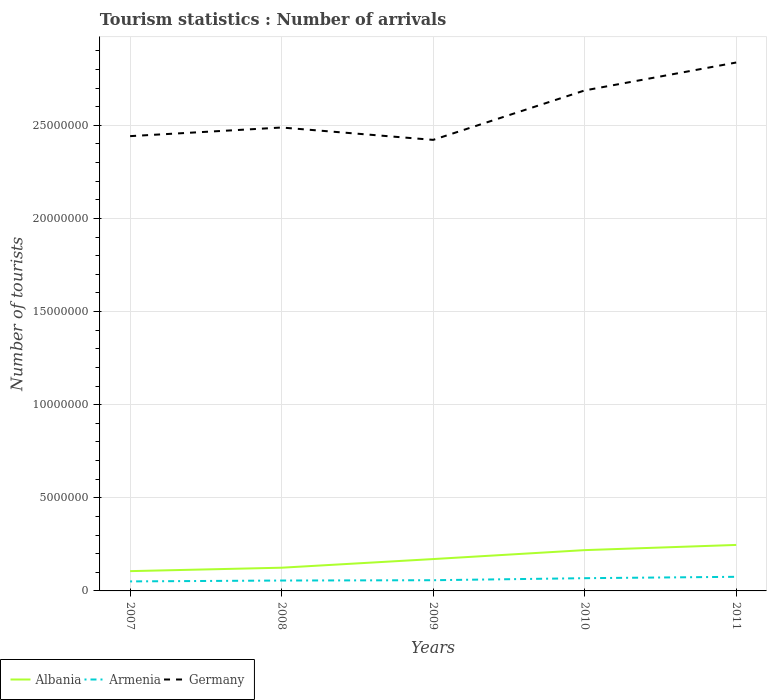Does the line corresponding to Germany intersect with the line corresponding to Armenia?
Keep it short and to the point. No. Across all years, what is the maximum number of tourist arrivals in Albania?
Make the answer very short. 1.06e+06. What is the total number of tourist arrivals in Albania in the graph?
Provide a succinct answer. -4.64e+05. What is the difference between the highest and the second highest number of tourist arrivals in Germany?
Offer a very short reply. 4.15e+06. What is the difference between the highest and the lowest number of tourist arrivals in Albania?
Ensure brevity in your answer.  2. Is the number of tourist arrivals in Armenia strictly greater than the number of tourist arrivals in Albania over the years?
Offer a terse response. Yes. How many lines are there?
Provide a short and direct response. 3. Where does the legend appear in the graph?
Your response must be concise. Bottom left. How many legend labels are there?
Provide a short and direct response. 3. What is the title of the graph?
Give a very brief answer. Tourism statistics : Number of arrivals. Does "Haiti" appear as one of the legend labels in the graph?
Offer a very short reply. No. What is the label or title of the X-axis?
Your response must be concise. Years. What is the label or title of the Y-axis?
Offer a terse response. Number of tourists. What is the Number of tourists of Albania in 2007?
Offer a very short reply. 1.06e+06. What is the Number of tourists of Armenia in 2007?
Give a very brief answer. 5.11e+05. What is the Number of tourists in Germany in 2007?
Offer a very short reply. 2.44e+07. What is the Number of tourists of Albania in 2008?
Offer a very short reply. 1.25e+06. What is the Number of tourists of Armenia in 2008?
Your answer should be very brief. 5.58e+05. What is the Number of tourists in Germany in 2008?
Make the answer very short. 2.49e+07. What is the Number of tourists in Albania in 2009?
Provide a short and direct response. 1.71e+06. What is the Number of tourists in Armenia in 2009?
Provide a succinct answer. 5.75e+05. What is the Number of tourists in Germany in 2009?
Your response must be concise. 2.42e+07. What is the Number of tourists of Albania in 2010?
Provide a short and direct response. 2.19e+06. What is the Number of tourists of Armenia in 2010?
Keep it short and to the point. 6.84e+05. What is the Number of tourists of Germany in 2010?
Offer a very short reply. 2.69e+07. What is the Number of tourists in Albania in 2011?
Give a very brief answer. 2.47e+06. What is the Number of tourists of Armenia in 2011?
Offer a very short reply. 7.58e+05. What is the Number of tourists of Germany in 2011?
Your answer should be compact. 2.84e+07. Across all years, what is the maximum Number of tourists in Albania?
Ensure brevity in your answer.  2.47e+06. Across all years, what is the maximum Number of tourists of Armenia?
Provide a short and direct response. 7.58e+05. Across all years, what is the maximum Number of tourists of Germany?
Your response must be concise. 2.84e+07. Across all years, what is the minimum Number of tourists in Albania?
Offer a very short reply. 1.06e+06. Across all years, what is the minimum Number of tourists of Armenia?
Give a very brief answer. 5.11e+05. Across all years, what is the minimum Number of tourists in Germany?
Ensure brevity in your answer.  2.42e+07. What is the total Number of tourists of Albania in the graph?
Provide a short and direct response. 8.68e+06. What is the total Number of tourists in Armenia in the graph?
Your answer should be very brief. 3.09e+06. What is the total Number of tourists in Germany in the graph?
Your answer should be compact. 1.29e+08. What is the difference between the Number of tourists in Albania in 2007 and that in 2008?
Keep it short and to the point. -1.85e+05. What is the difference between the Number of tourists in Armenia in 2007 and that in 2008?
Offer a very short reply. -4.70e+04. What is the difference between the Number of tourists of Germany in 2007 and that in 2008?
Your answer should be compact. -4.63e+05. What is the difference between the Number of tourists of Albania in 2007 and that in 2009?
Provide a short and direct response. -6.49e+05. What is the difference between the Number of tourists in Armenia in 2007 and that in 2009?
Give a very brief answer. -6.40e+04. What is the difference between the Number of tourists of Germany in 2007 and that in 2009?
Keep it short and to the point. 2.01e+05. What is the difference between the Number of tourists of Albania in 2007 and that in 2010?
Provide a succinct answer. -1.13e+06. What is the difference between the Number of tourists in Armenia in 2007 and that in 2010?
Give a very brief answer. -1.73e+05. What is the difference between the Number of tourists in Germany in 2007 and that in 2010?
Keep it short and to the point. -2.45e+06. What is the difference between the Number of tourists of Albania in 2007 and that in 2011?
Your answer should be compact. -1.41e+06. What is the difference between the Number of tourists of Armenia in 2007 and that in 2011?
Your answer should be very brief. -2.47e+05. What is the difference between the Number of tourists in Germany in 2007 and that in 2011?
Provide a succinct answer. -3.95e+06. What is the difference between the Number of tourists of Albania in 2008 and that in 2009?
Make the answer very short. -4.64e+05. What is the difference between the Number of tourists in Armenia in 2008 and that in 2009?
Your answer should be compact. -1.70e+04. What is the difference between the Number of tourists of Germany in 2008 and that in 2009?
Provide a succinct answer. 6.64e+05. What is the difference between the Number of tourists in Albania in 2008 and that in 2010?
Your answer should be very brief. -9.44e+05. What is the difference between the Number of tourists in Armenia in 2008 and that in 2010?
Make the answer very short. -1.26e+05. What is the difference between the Number of tourists in Germany in 2008 and that in 2010?
Give a very brief answer. -1.99e+06. What is the difference between the Number of tourists of Albania in 2008 and that in 2011?
Provide a short and direct response. -1.22e+06. What is the difference between the Number of tourists in Armenia in 2008 and that in 2011?
Offer a terse response. -2.00e+05. What is the difference between the Number of tourists of Germany in 2008 and that in 2011?
Your response must be concise. -3.49e+06. What is the difference between the Number of tourists of Albania in 2009 and that in 2010?
Ensure brevity in your answer.  -4.80e+05. What is the difference between the Number of tourists of Armenia in 2009 and that in 2010?
Ensure brevity in your answer.  -1.09e+05. What is the difference between the Number of tourists in Germany in 2009 and that in 2010?
Your answer should be compact. -2.66e+06. What is the difference between the Number of tourists in Albania in 2009 and that in 2011?
Ensure brevity in your answer.  -7.58e+05. What is the difference between the Number of tourists of Armenia in 2009 and that in 2011?
Provide a succinct answer. -1.83e+05. What is the difference between the Number of tourists in Germany in 2009 and that in 2011?
Offer a terse response. -4.15e+06. What is the difference between the Number of tourists of Albania in 2010 and that in 2011?
Make the answer very short. -2.78e+05. What is the difference between the Number of tourists of Armenia in 2010 and that in 2011?
Offer a very short reply. -7.40e+04. What is the difference between the Number of tourists in Germany in 2010 and that in 2011?
Keep it short and to the point. -1.50e+06. What is the difference between the Number of tourists of Albania in 2007 and the Number of tourists of Armenia in 2008?
Your response must be concise. 5.04e+05. What is the difference between the Number of tourists in Albania in 2007 and the Number of tourists in Germany in 2008?
Keep it short and to the point. -2.38e+07. What is the difference between the Number of tourists of Armenia in 2007 and the Number of tourists of Germany in 2008?
Give a very brief answer. -2.44e+07. What is the difference between the Number of tourists in Albania in 2007 and the Number of tourists in Armenia in 2009?
Give a very brief answer. 4.87e+05. What is the difference between the Number of tourists in Albania in 2007 and the Number of tourists in Germany in 2009?
Your answer should be compact. -2.32e+07. What is the difference between the Number of tourists of Armenia in 2007 and the Number of tourists of Germany in 2009?
Keep it short and to the point. -2.37e+07. What is the difference between the Number of tourists of Albania in 2007 and the Number of tourists of Armenia in 2010?
Your answer should be very brief. 3.78e+05. What is the difference between the Number of tourists in Albania in 2007 and the Number of tourists in Germany in 2010?
Make the answer very short. -2.58e+07. What is the difference between the Number of tourists in Armenia in 2007 and the Number of tourists in Germany in 2010?
Your response must be concise. -2.64e+07. What is the difference between the Number of tourists in Albania in 2007 and the Number of tourists in Armenia in 2011?
Keep it short and to the point. 3.04e+05. What is the difference between the Number of tourists of Albania in 2007 and the Number of tourists of Germany in 2011?
Offer a terse response. -2.73e+07. What is the difference between the Number of tourists of Armenia in 2007 and the Number of tourists of Germany in 2011?
Give a very brief answer. -2.79e+07. What is the difference between the Number of tourists of Albania in 2008 and the Number of tourists of Armenia in 2009?
Give a very brief answer. 6.72e+05. What is the difference between the Number of tourists of Albania in 2008 and the Number of tourists of Germany in 2009?
Offer a very short reply. -2.30e+07. What is the difference between the Number of tourists in Armenia in 2008 and the Number of tourists in Germany in 2009?
Provide a short and direct response. -2.37e+07. What is the difference between the Number of tourists of Albania in 2008 and the Number of tourists of Armenia in 2010?
Offer a terse response. 5.63e+05. What is the difference between the Number of tourists of Albania in 2008 and the Number of tourists of Germany in 2010?
Give a very brief answer. -2.56e+07. What is the difference between the Number of tourists of Armenia in 2008 and the Number of tourists of Germany in 2010?
Ensure brevity in your answer.  -2.63e+07. What is the difference between the Number of tourists of Albania in 2008 and the Number of tourists of Armenia in 2011?
Offer a very short reply. 4.89e+05. What is the difference between the Number of tourists in Albania in 2008 and the Number of tourists in Germany in 2011?
Make the answer very short. -2.71e+07. What is the difference between the Number of tourists in Armenia in 2008 and the Number of tourists in Germany in 2011?
Make the answer very short. -2.78e+07. What is the difference between the Number of tourists of Albania in 2009 and the Number of tourists of Armenia in 2010?
Keep it short and to the point. 1.03e+06. What is the difference between the Number of tourists in Albania in 2009 and the Number of tourists in Germany in 2010?
Your answer should be very brief. -2.52e+07. What is the difference between the Number of tourists in Armenia in 2009 and the Number of tourists in Germany in 2010?
Your answer should be very brief. -2.63e+07. What is the difference between the Number of tourists of Albania in 2009 and the Number of tourists of Armenia in 2011?
Offer a terse response. 9.53e+05. What is the difference between the Number of tourists of Albania in 2009 and the Number of tourists of Germany in 2011?
Provide a short and direct response. -2.67e+07. What is the difference between the Number of tourists in Armenia in 2009 and the Number of tourists in Germany in 2011?
Ensure brevity in your answer.  -2.78e+07. What is the difference between the Number of tourists in Albania in 2010 and the Number of tourists in Armenia in 2011?
Provide a succinct answer. 1.43e+06. What is the difference between the Number of tourists of Albania in 2010 and the Number of tourists of Germany in 2011?
Ensure brevity in your answer.  -2.62e+07. What is the difference between the Number of tourists of Armenia in 2010 and the Number of tourists of Germany in 2011?
Provide a succinct answer. -2.77e+07. What is the average Number of tourists in Albania per year?
Make the answer very short. 1.74e+06. What is the average Number of tourists of Armenia per year?
Ensure brevity in your answer.  6.17e+05. What is the average Number of tourists in Germany per year?
Your answer should be very brief. 2.58e+07. In the year 2007, what is the difference between the Number of tourists of Albania and Number of tourists of Armenia?
Your answer should be very brief. 5.51e+05. In the year 2007, what is the difference between the Number of tourists in Albania and Number of tourists in Germany?
Provide a short and direct response. -2.34e+07. In the year 2007, what is the difference between the Number of tourists in Armenia and Number of tourists in Germany?
Your response must be concise. -2.39e+07. In the year 2008, what is the difference between the Number of tourists in Albania and Number of tourists in Armenia?
Offer a very short reply. 6.89e+05. In the year 2008, what is the difference between the Number of tourists in Albania and Number of tourists in Germany?
Make the answer very short. -2.36e+07. In the year 2008, what is the difference between the Number of tourists in Armenia and Number of tourists in Germany?
Provide a succinct answer. -2.43e+07. In the year 2009, what is the difference between the Number of tourists of Albania and Number of tourists of Armenia?
Keep it short and to the point. 1.14e+06. In the year 2009, what is the difference between the Number of tourists of Albania and Number of tourists of Germany?
Provide a short and direct response. -2.25e+07. In the year 2009, what is the difference between the Number of tourists of Armenia and Number of tourists of Germany?
Offer a very short reply. -2.36e+07. In the year 2010, what is the difference between the Number of tourists in Albania and Number of tourists in Armenia?
Offer a very short reply. 1.51e+06. In the year 2010, what is the difference between the Number of tourists in Albania and Number of tourists in Germany?
Ensure brevity in your answer.  -2.47e+07. In the year 2010, what is the difference between the Number of tourists in Armenia and Number of tourists in Germany?
Give a very brief answer. -2.62e+07. In the year 2011, what is the difference between the Number of tourists in Albania and Number of tourists in Armenia?
Give a very brief answer. 1.71e+06. In the year 2011, what is the difference between the Number of tourists of Albania and Number of tourists of Germany?
Make the answer very short. -2.59e+07. In the year 2011, what is the difference between the Number of tourists of Armenia and Number of tourists of Germany?
Give a very brief answer. -2.76e+07. What is the ratio of the Number of tourists in Albania in 2007 to that in 2008?
Your answer should be very brief. 0.85. What is the ratio of the Number of tourists in Armenia in 2007 to that in 2008?
Ensure brevity in your answer.  0.92. What is the ratio of the Number of tourists in Germany in 2007 to that in 2008?
Offer a very short reply. 0.98. What is the ratio of the Number of tourists in Albania in 2007 to that in 2009?
Your response must be concise. 0.62. What is the ratio of the Number of tourists in Armenia in 2007 to that in 2009?
Ensure brevity in your answer.  0.89. What is the ratio of the Number of tourists in Germany in 2007 to that in 2009?
Your answer should be compact. 1.01. What is the ratio of the Number of tourists of Albania in 2007 to that in 2010?
Make the answer very short. 0.48. What is the ratio of the Number of tourists of Armenia in 2007 to that in 2010?
Give a very brief answer. 0.75. What is the ratio of the Number of tourists in Germany in 2007 to that in 2010?
Your response must be concise. 0.91. What is the ratio of the Number of tourists of Albania in 2007 to that in 2011?
Your answer should be compact. 0.43. What is the ratio of the Number of tourists in Armenia in 2007 to that in 2011?
Make the answer very short. 0.67. What is the ratio of the Number of tourists of Germany in 2007 to that in 2011?
Your answer should be very brief. 0.86. What is the ratio of the Number of tourists in Albania in 2008 to that in 2009?
Your answer should be very brief. 0.73. What is the ratio of the Number of tourists in Armenia in 2008 to that in 2009?
Your response must be concise. 0.97. What is the ratio of the Number of tourists of Germany in 2008 to that in 2009?
Your answer should be compact. 1.03. What is the ratio of the Number of tourists in Albania in 2008 to that in 2010?
Offer a terse response. 0.57. What is the ratio of the Number of tourists in Armenia in 2008 to that in 2010?
Keep it short and to the point. 0.82. What is the ratio of the Number of tourists of Germany in 2008 to that in 2010?
Your answer should be very brief. 0.93. What is the ratio of the Number of tourists in Albania in 2008 to that in 2011?
Keep it short and to the point. 0.51. What is the ratio of the Number of tourists in Armenia in 2008 to that in 2011?
Offer a very short reply. 0.74. What is the ratio of the Number of tourists of Germany in 2008 to that in 2011?
Provide a short and direct response. 0.88. What is the ratio of the Number of tourists of Albania in 2009 to that in 2010?
Keep it short and to the point. 0.78. What is the ratio of the Number of tourists of Armenia in 2009 to that in 2010?
Provide a succinct answer. 0.84. What is the ratio of the Number of tourists of Germany in 2009 to that in 2010?
Make the answer very short. 0.9. What is the ratio of the Number of tourists of Albania in 2009 to that in 2011?
Offer a very short reply. 0.69. What is the ratio of the Number of tourists in Armenia in 2009 to that in 2011?
Keep it short and to the point. 0.76. What is the ratio of the Number of tourists in Germany in 2009 to that in 2011?
Give a very brief answer. 0.85. What is the ratio of the Number of tourists in Albania in 2010 to that in 2011?
Your answer should be compact. 0.89. What is the ratio of the Number of tourists of Armenia in 2010 to that in 2011?
Give a very brief answer. 0.9. What is the ratio of the Number of tourists in Germany in 2010 to that in 2011?
Provide a succinct answer. 0.95. What is the difference between the highest and the second highest Number of tourists of Albania?
Give a very brief answer. 2.78e+05. What is the difference between the highest and the second highest Number of tourists in Armenia?
Give a very brief answer. 7.40e+04. What is the difference between the highest and the second highest Number of tourists in Germany?
Provide a short and direct response. 1.50e+06. What is the difference between the highest and the lowest Number of tourists in Albania?
Give a very brief answer. 1.41e+06. What is the difference between the highest and the lowest Number of tourists in Armenia?
Your answer should be compact. 2.47e+05. What is the difference between the highest and the lowest Number of tourists in Germany?
Your answer should be very brief. 4.15e+06. 